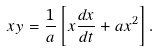<formula> <loc_0><loc_0><loc_500><loc_500>x y = \frac { 1 } { a } \left [ x \frac { d x } { d t } + a x ^ { 2 } \right ] .</formula> 